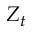Convert formula to latex. <formula><loc_0><loc_0><loc_500><loc_500>Z _ { t }</formula> 